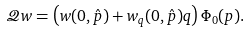<formula> <loc_0><loc_0><loc_500><loc_500>\mathcal { Q } w = \left ( w ( 0 , \hat { p } ) + w _ { q } ( 0 , \hat { p } ) q \right ) \Phi _ { 0 } ( p ) .</formula> 